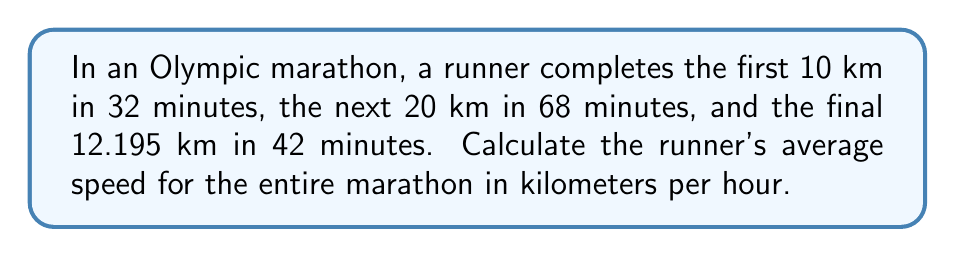Can you solve this math problem? Let's approach this step-by-step:

1) First, let's calculate the total distance of the marathon:
   $10 + 20 + 12.195 = 42.195$ km

2) Now, let's calculate the total time:
   $32 + 68 + 42 = 142$ minutes

3) Convert the time to hours:
   $142 \text{ minutes} = \frac{142}{60} = 2.3667$ hours

4) The formula for average speed is:
   $\text{Average Speed} = \frac{\text{Total Distance}}{\text{Total Time}}$

5) Plugging in our values:
   $$\text{Average Speed} = \frac{42.195 \text{ km}}{2.3667 \text{ hours}}$$

6) Performing the division:
   $$\text{Average Speed} = 17.8287 \text{ km/h}$$

7) Rounding to two decimal places:
   $$\text{Average Speed} \approx 17.83 \text{ km/h}$$
Answer: 17.83 km/h 